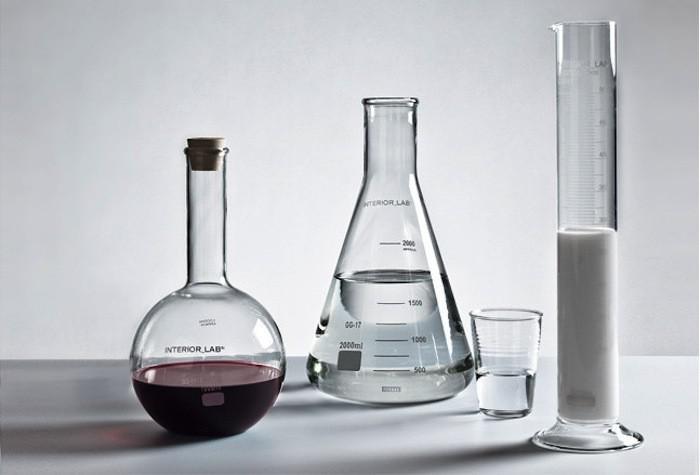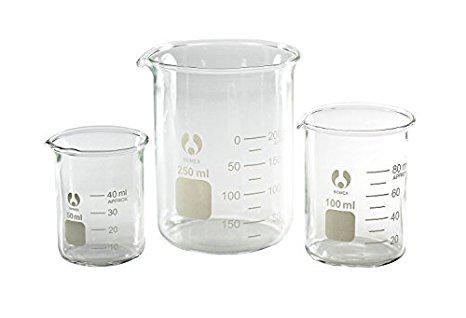The first image is the image on the left, the second image is the image on the right. Examine the images to the left and right. Is the description "One of the liquids is green." accurate? Answer yes or no. No. The first image is the image on the left, the second image is the image on the right. Evaluate the accuracy of this statement regarding the images: "There is only one beaker in one of the images, and it has some liquid inside it.". Is it true? Answer yes or no. No. 